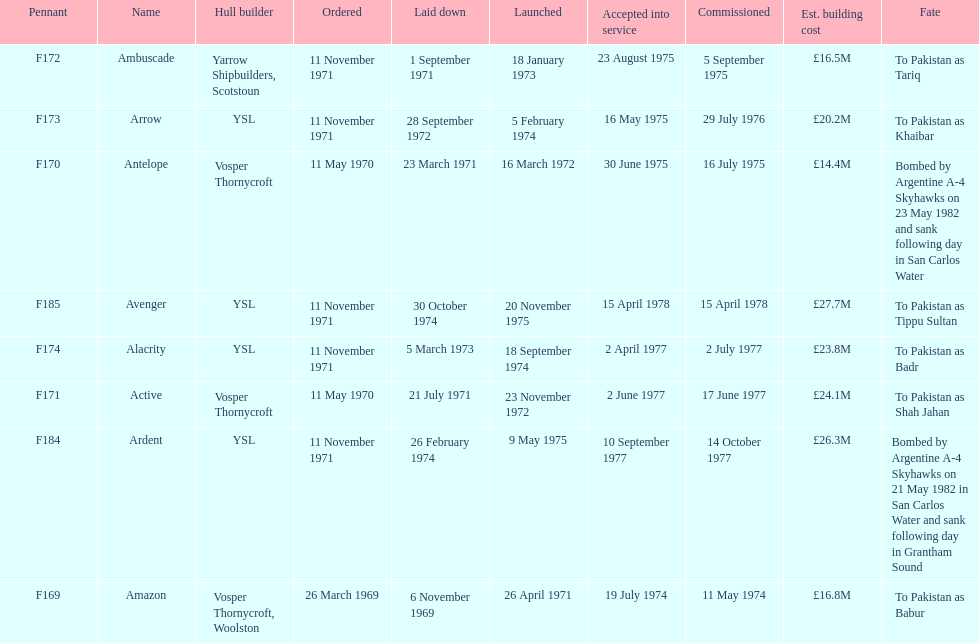How many ships were laid down in september? 2. Would you be able to parse every entry in this table? {'header': ['Pennant', 'Name', 'Hull builder', 'Ordered', 'Laid down', 'Launched', 'Accepted into service', 'Commissioned', 'Est. building cost', 'Fate'], 'rows': [['F172', 'Ambuscade', 'Yarrow Shipbuilders, Scotstoun', '11 November 1971', '1 September 1971', '18 January 1973', '23 August 1975', '5 September 1975', '£16.5M', 'To Pakistan as Tariq'], ['F173', 'Arrow', 'YSL', '11 November 1971', '28 September 1972', '5 February 1974', '16 May 1975', '29 July 1976', '£20.2M', 'To Pakistan as Khaibar'], ['F170', 'Antelope', 'Vosper Thornycroft', '11 May 1970', '23 March 1971', '16 March 1972', '30 June 1975', '16 July 1975', '£14.4M', 'Bombed by Argentine A-4 Skyhawks on 23 May 1982 and sank following day in San Carlos Water'], ['F185', 'Avenger', 'YSL', '11 November 1971', '30 October 1974', '20 November 1975', '15 April 1978', '15 April 1978', '£27.7M', 'To Pakistan as Tippu Sultan'], ['F174', 'Alacrity', 'YSL', '11 November 1971', '5 March 1973', '18 September 1974', '2 April 1977', '2 July 1977', '£23.8M', 'To Pakistan as Badr'], ['F171', 'Active', 'Vosper Thornycroft', '11 May 1970', '21 July 1971', '23 November 1972', '2 June 1977', '17 June 1977', '£24.1M', 'To Pakistan as Shah Jahan'], ['F184', 'Ardent', 'YSL', '11 November 1971', '26 February 1974', '9 May 1975', '10 September 1977', '14 October 1977', '£26.3M', 'Bombed by Argentine A-4 Skyhawks on 21 May 1982 in San Carlos Water and sank following day in Grantham Sound'], ['F169', 'Amazon', 'Vosper Thornycroft, Woolston', '26 March 1969', '6 November 1969', '26 April 1971', '19 July 1974', '11 May 1974', '£16.8M', 'To Pakistan as Babur']]} 